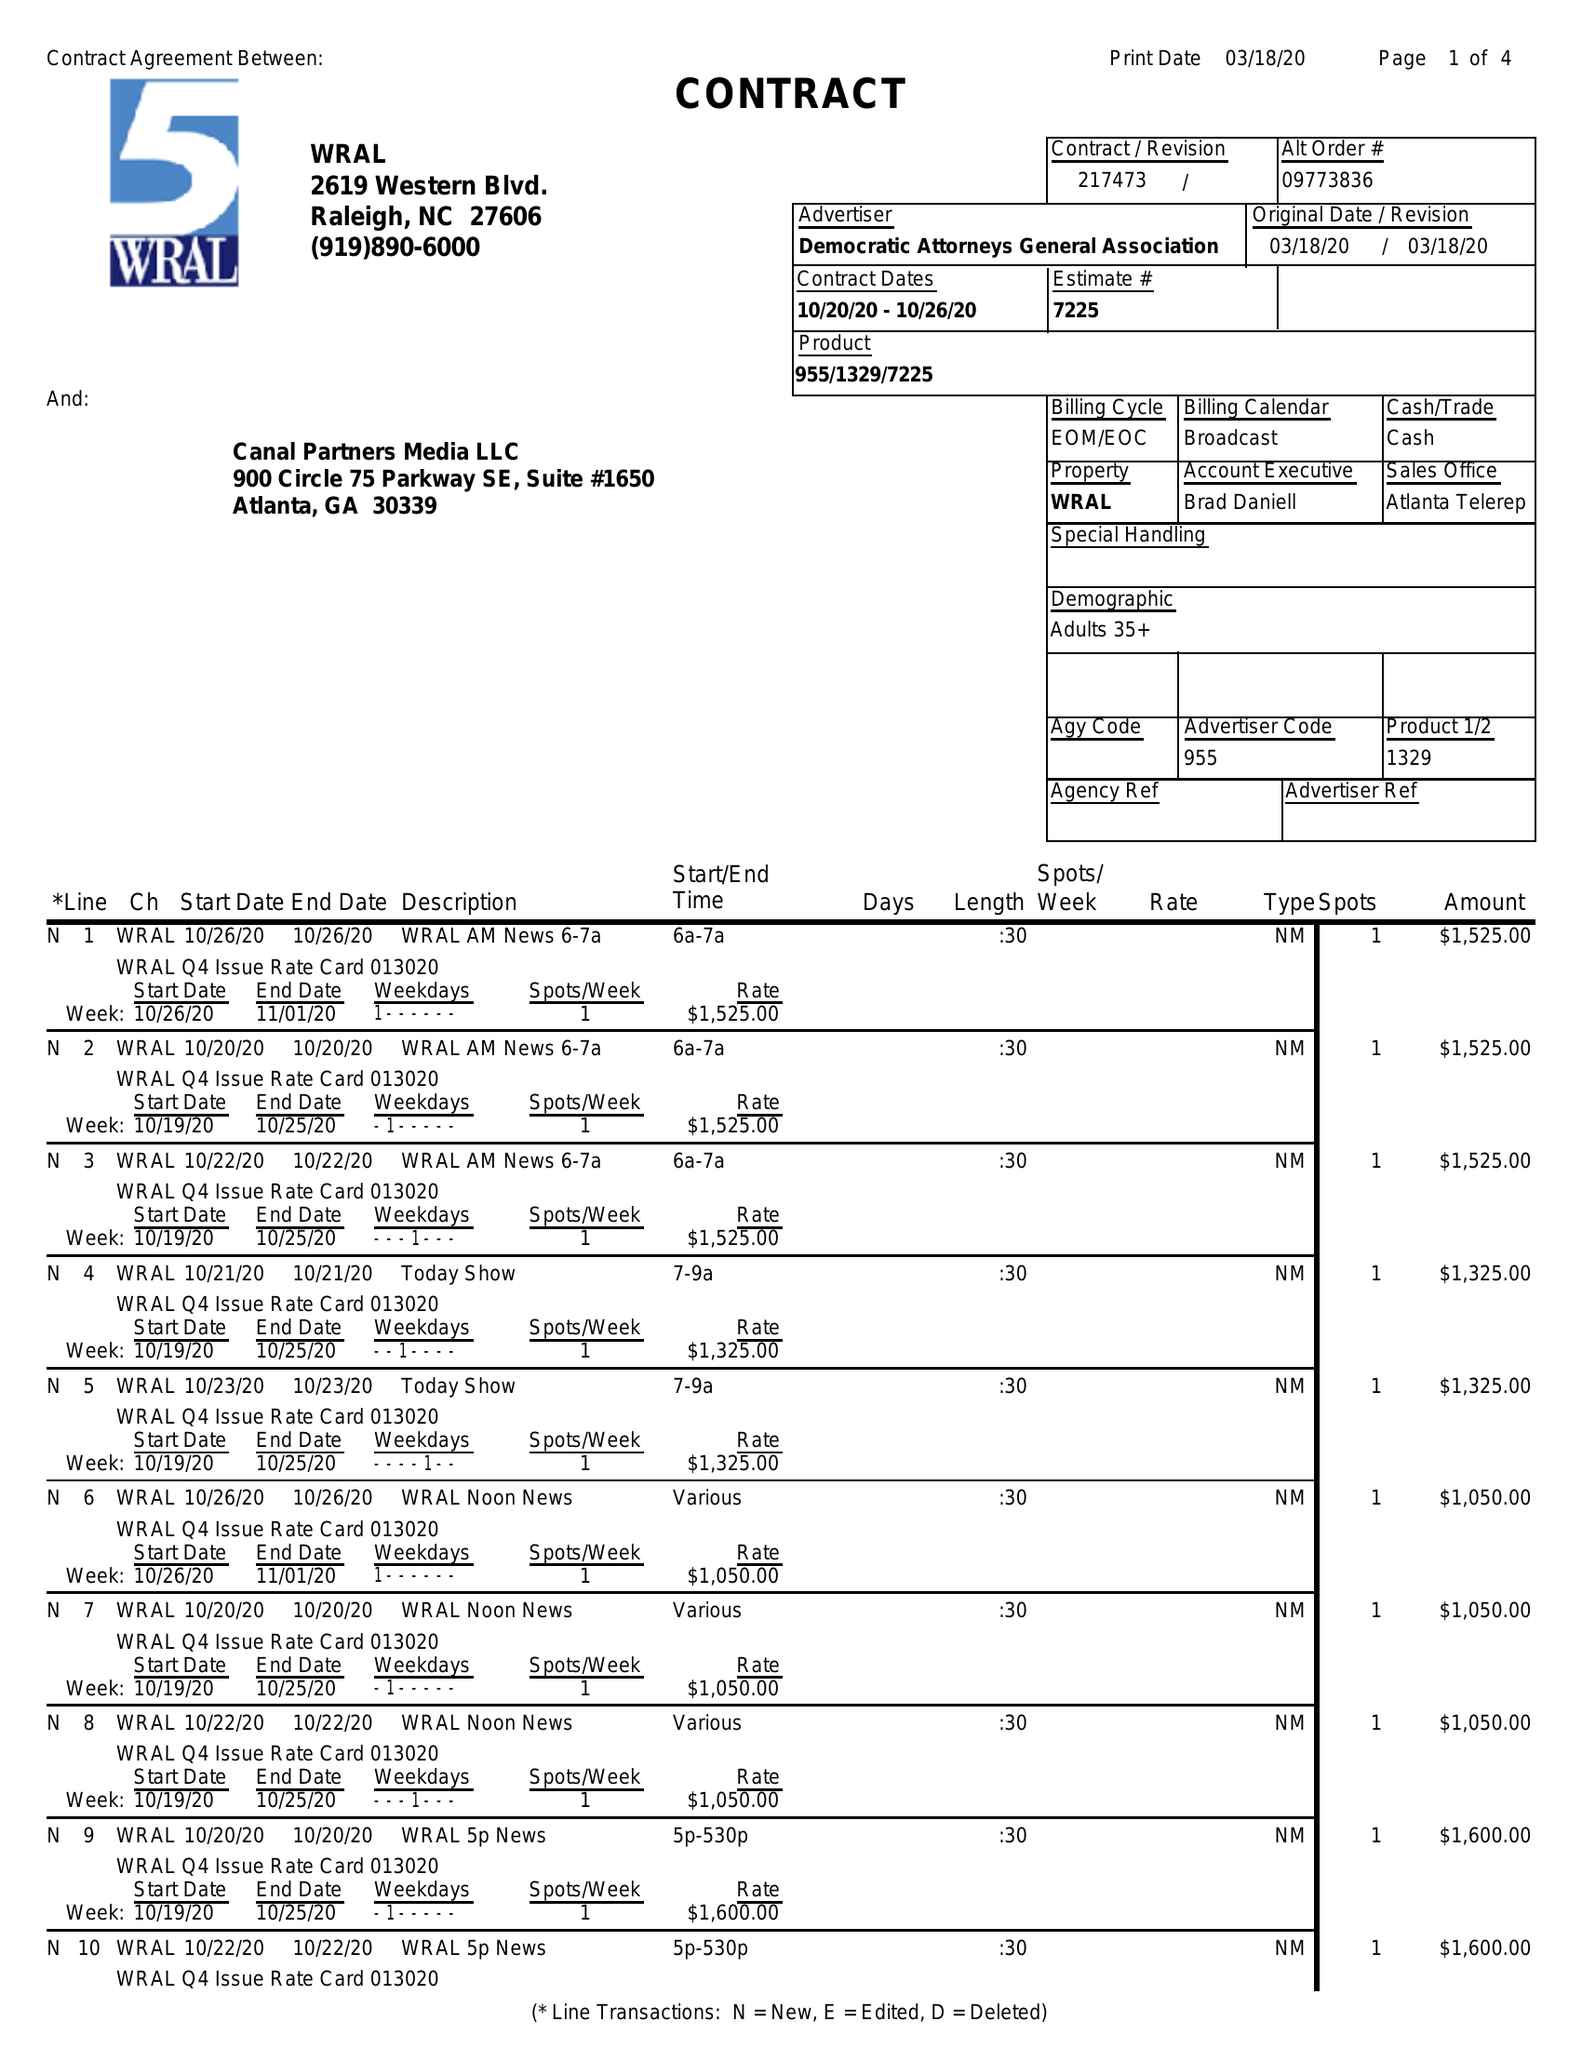What is the value for the gross_amount?
Answer the question using a single word or phrase. 36850.00 